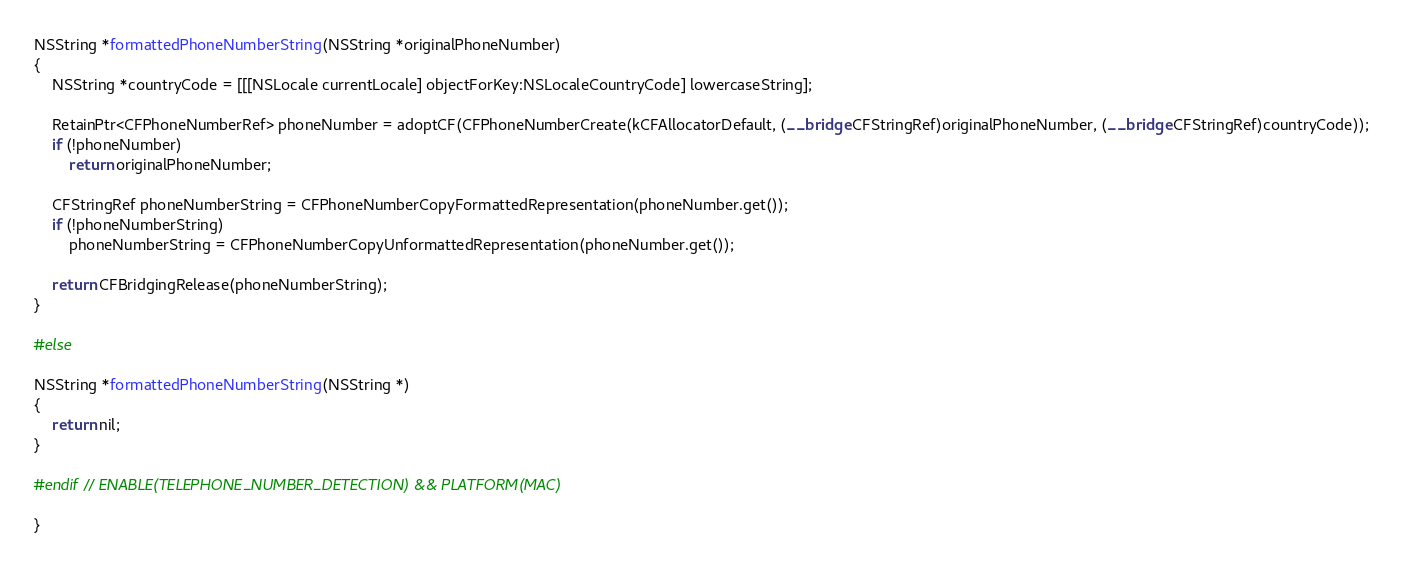Convert code to text. <code><loc_0><loc_0><loc_500><loc_500><_ObjectiveC_>NSString *formattedPhoneNumberString(NSString *originalPhoneNumber)
{
    NSString *countryCode = [[[NSLocale currentLocale] objectForKey:NSLocaleCountryCode] lowercaseString];

    RetainPtr<CFPhoneNumberRef> phoneNumber = adoptCF(CFPhoneNumberCreate(kCFAllocatorDefault, (__bridge CFStringRef)originalPhoneNumber, (__bridge CFStringRef)countryCode));
    if (!phoneNumber)
        return originalPhoneNumber;

    CFStringRef phoneNumberString = CFPhoneNumberCopyFormattedRepresentation(phoneNumber.get());
    if (!phoneNumberString)
        phoneNumberString = CFPhoneNumberCopyUnformattedRepresentation(phoneNumber.get());

    return CFBridgingRelease(phoneNumberString);
}

#else

NSString *formattedPhoneNumberString(NSString *)
{
    return nil;
}

#endif // ENABLE(TELEPHONE_NUMBER_DETECTION) && PLATFORM(MAC)

}
</code> 